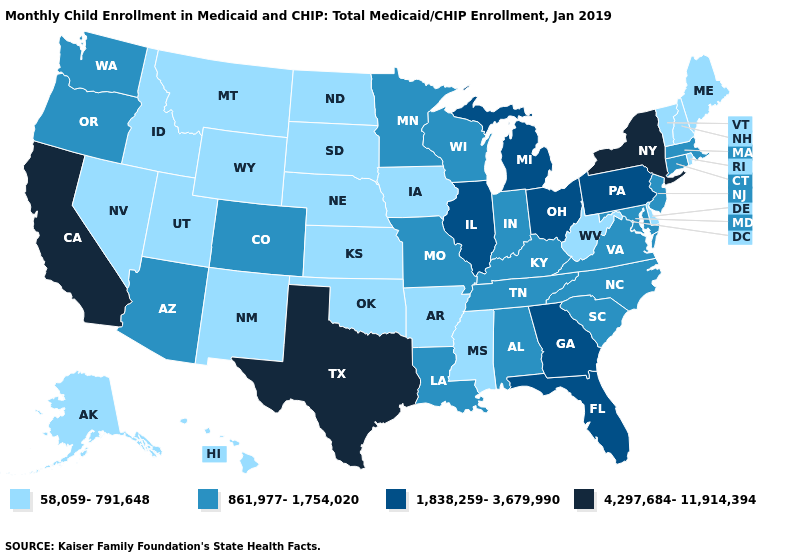Does the map have missing data?
Concise answer only. No. What is the value of California?
Be succinct. 4,297,684-11,914,394. What is the value of Minnesota?
Answer briefly. 861,977-1,754,020. How many symbols are there in the legend?
Short answer required. 4. Does Massachusetts have the highest value in the USA?
Write a very short answer. No. Does Missouri have the same value as Illinois?
Give a very brief answer. No. Does South Dakota have the lowest value in the USA?
Concise answer only. Yes. What is the highest value in the West ?
Short answer required. 4,297,684-11,914,394. What is the highest value in states that border California?
Write a very short answer. 861,977-1,754,020. Name the states that have a value in the range 4,297,684-11,914,394?
Answer briefly. California, New York, Texas. Does Virginia have the same value as Arizona?
Short answer required. Yes. Name the states that have a value in the range 58,059-791,648?
Be succinct. Alaska, Arkansas, Delaware, Hawaii, Idaho, Iowa, Kansas, Maine, Mississippi, Montana, Nebraska, Nevada, New Hampshire, New Mexico, North Dakota, Oklahoma, Rhode Island, South Dakota, Utah, Vermont, West Virginia, Wyoming. Does Maryland have a lower value than Indiana?
Be succinct. No. What is the value of South Dakota?
Short answer required. 58,059-791,648. Does Indiana have the highest value in the MidWest?
Concise answer only. No. 